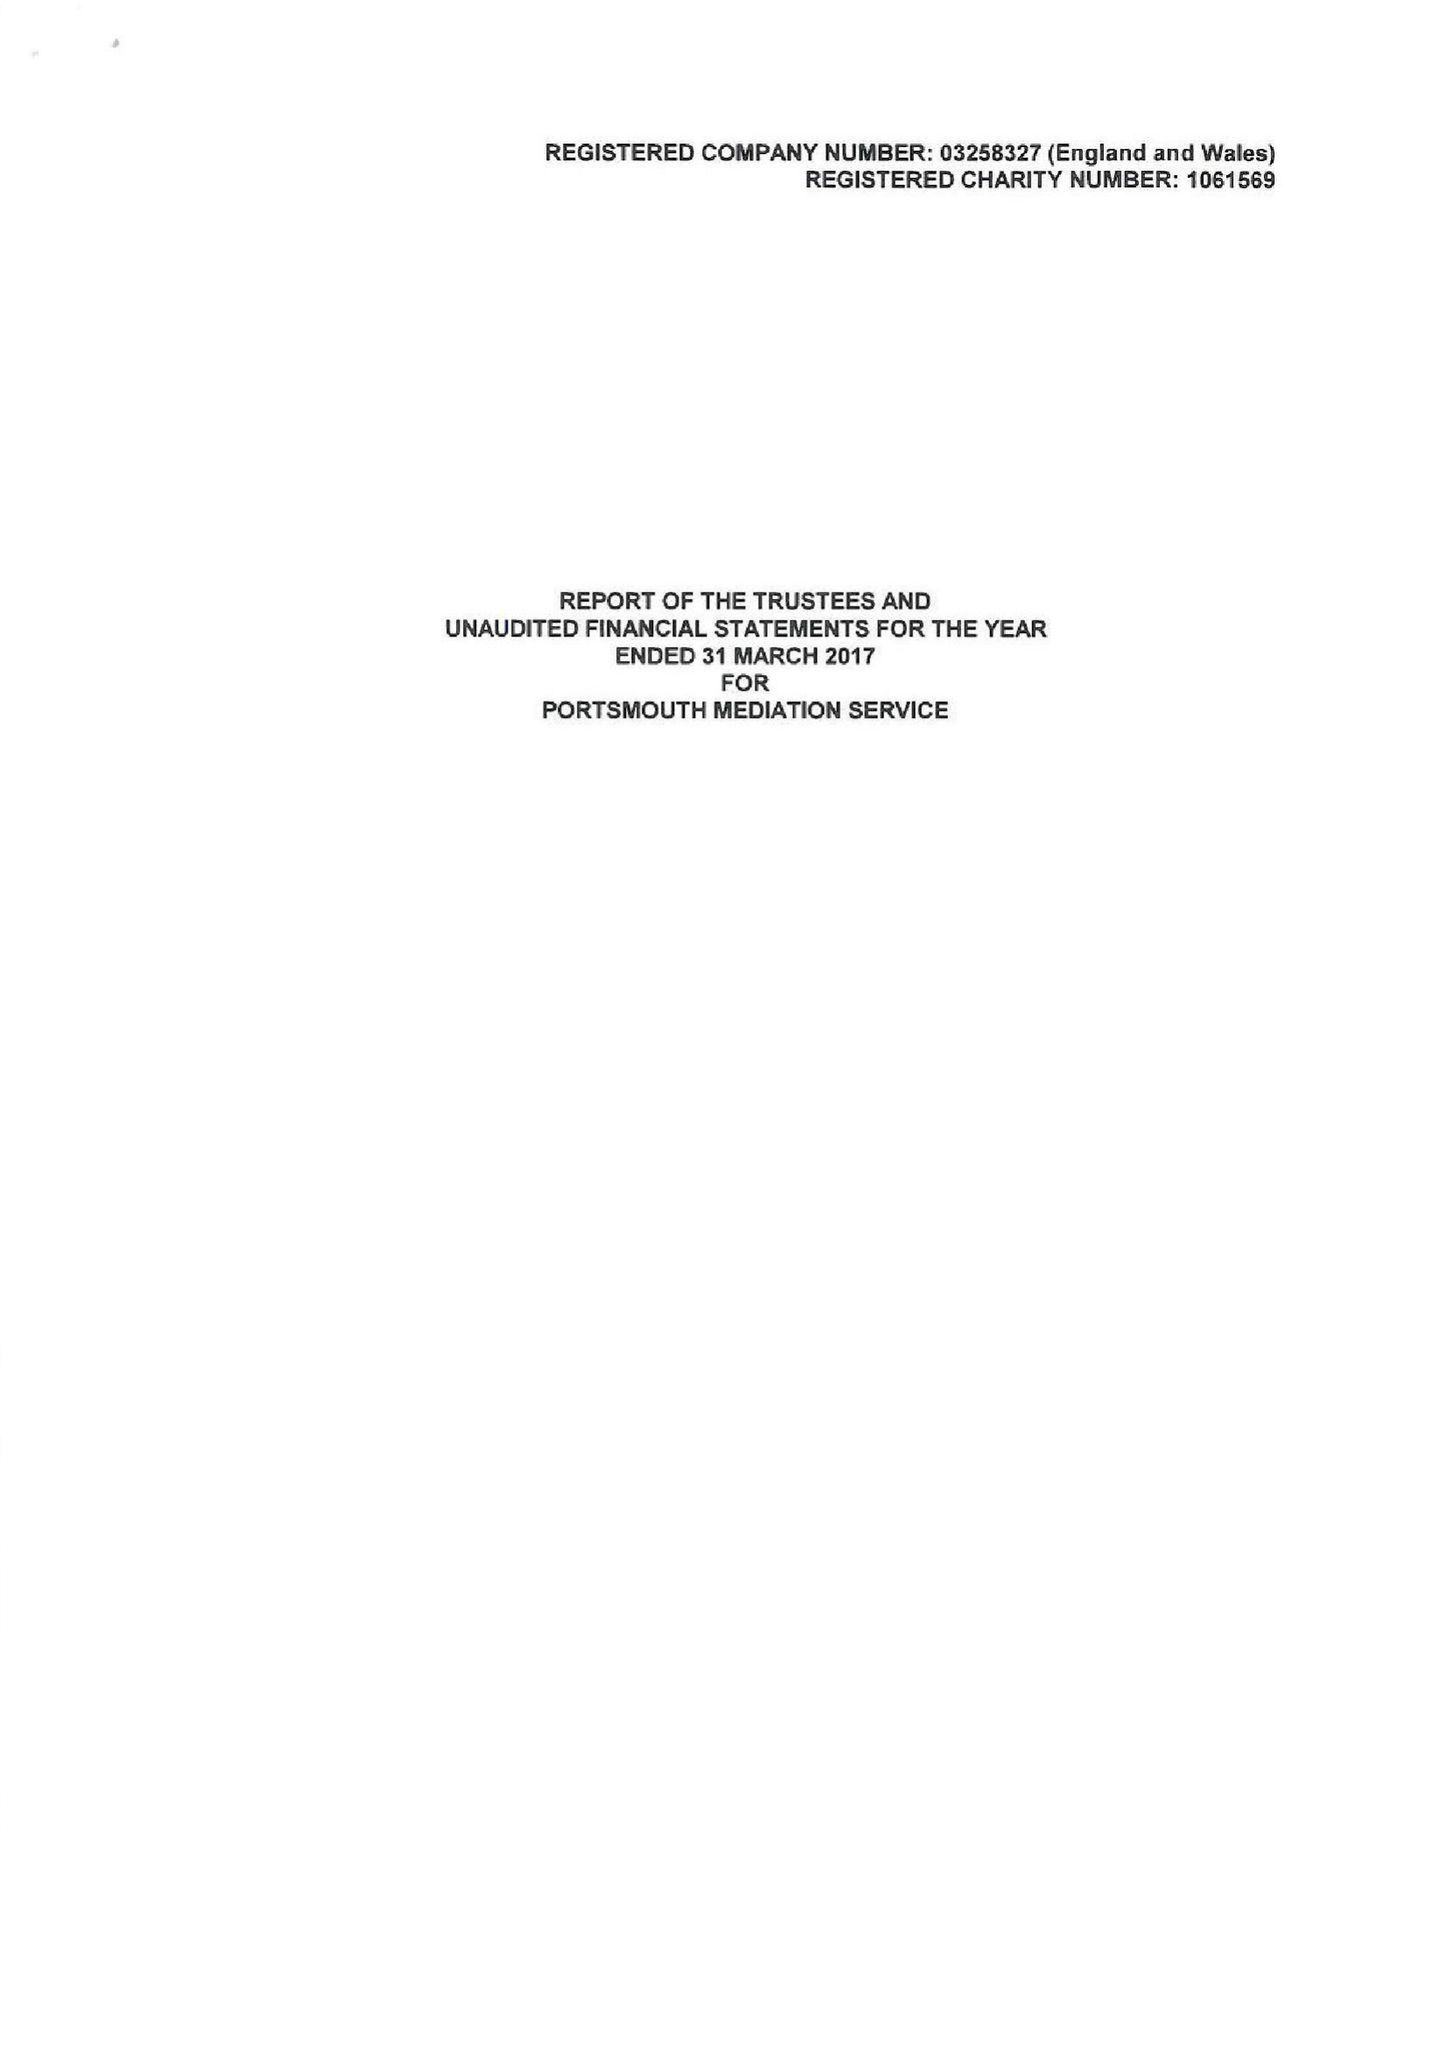What is the value for the spending_annually_in_british_pounds?
Answer the question using a single word or phrase. 156944.00 